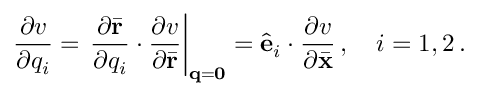Convert formula to latex. <formula><loc_0><loc_0><loc_500><loc_500>\frac { \partial v } { \partial q _ { i } } = \frac { \partial \bar { r } } { \partial q _ { i } } \cdot \frac { \partial v } { \partial \bar { r } } \right | _ { { q } = { 0 } } = \hat { e } _ { i } \cdot \frac { \partial v } { \partial \bar { x } } \, , \quad i = 1 , 2 \, .</formula> 